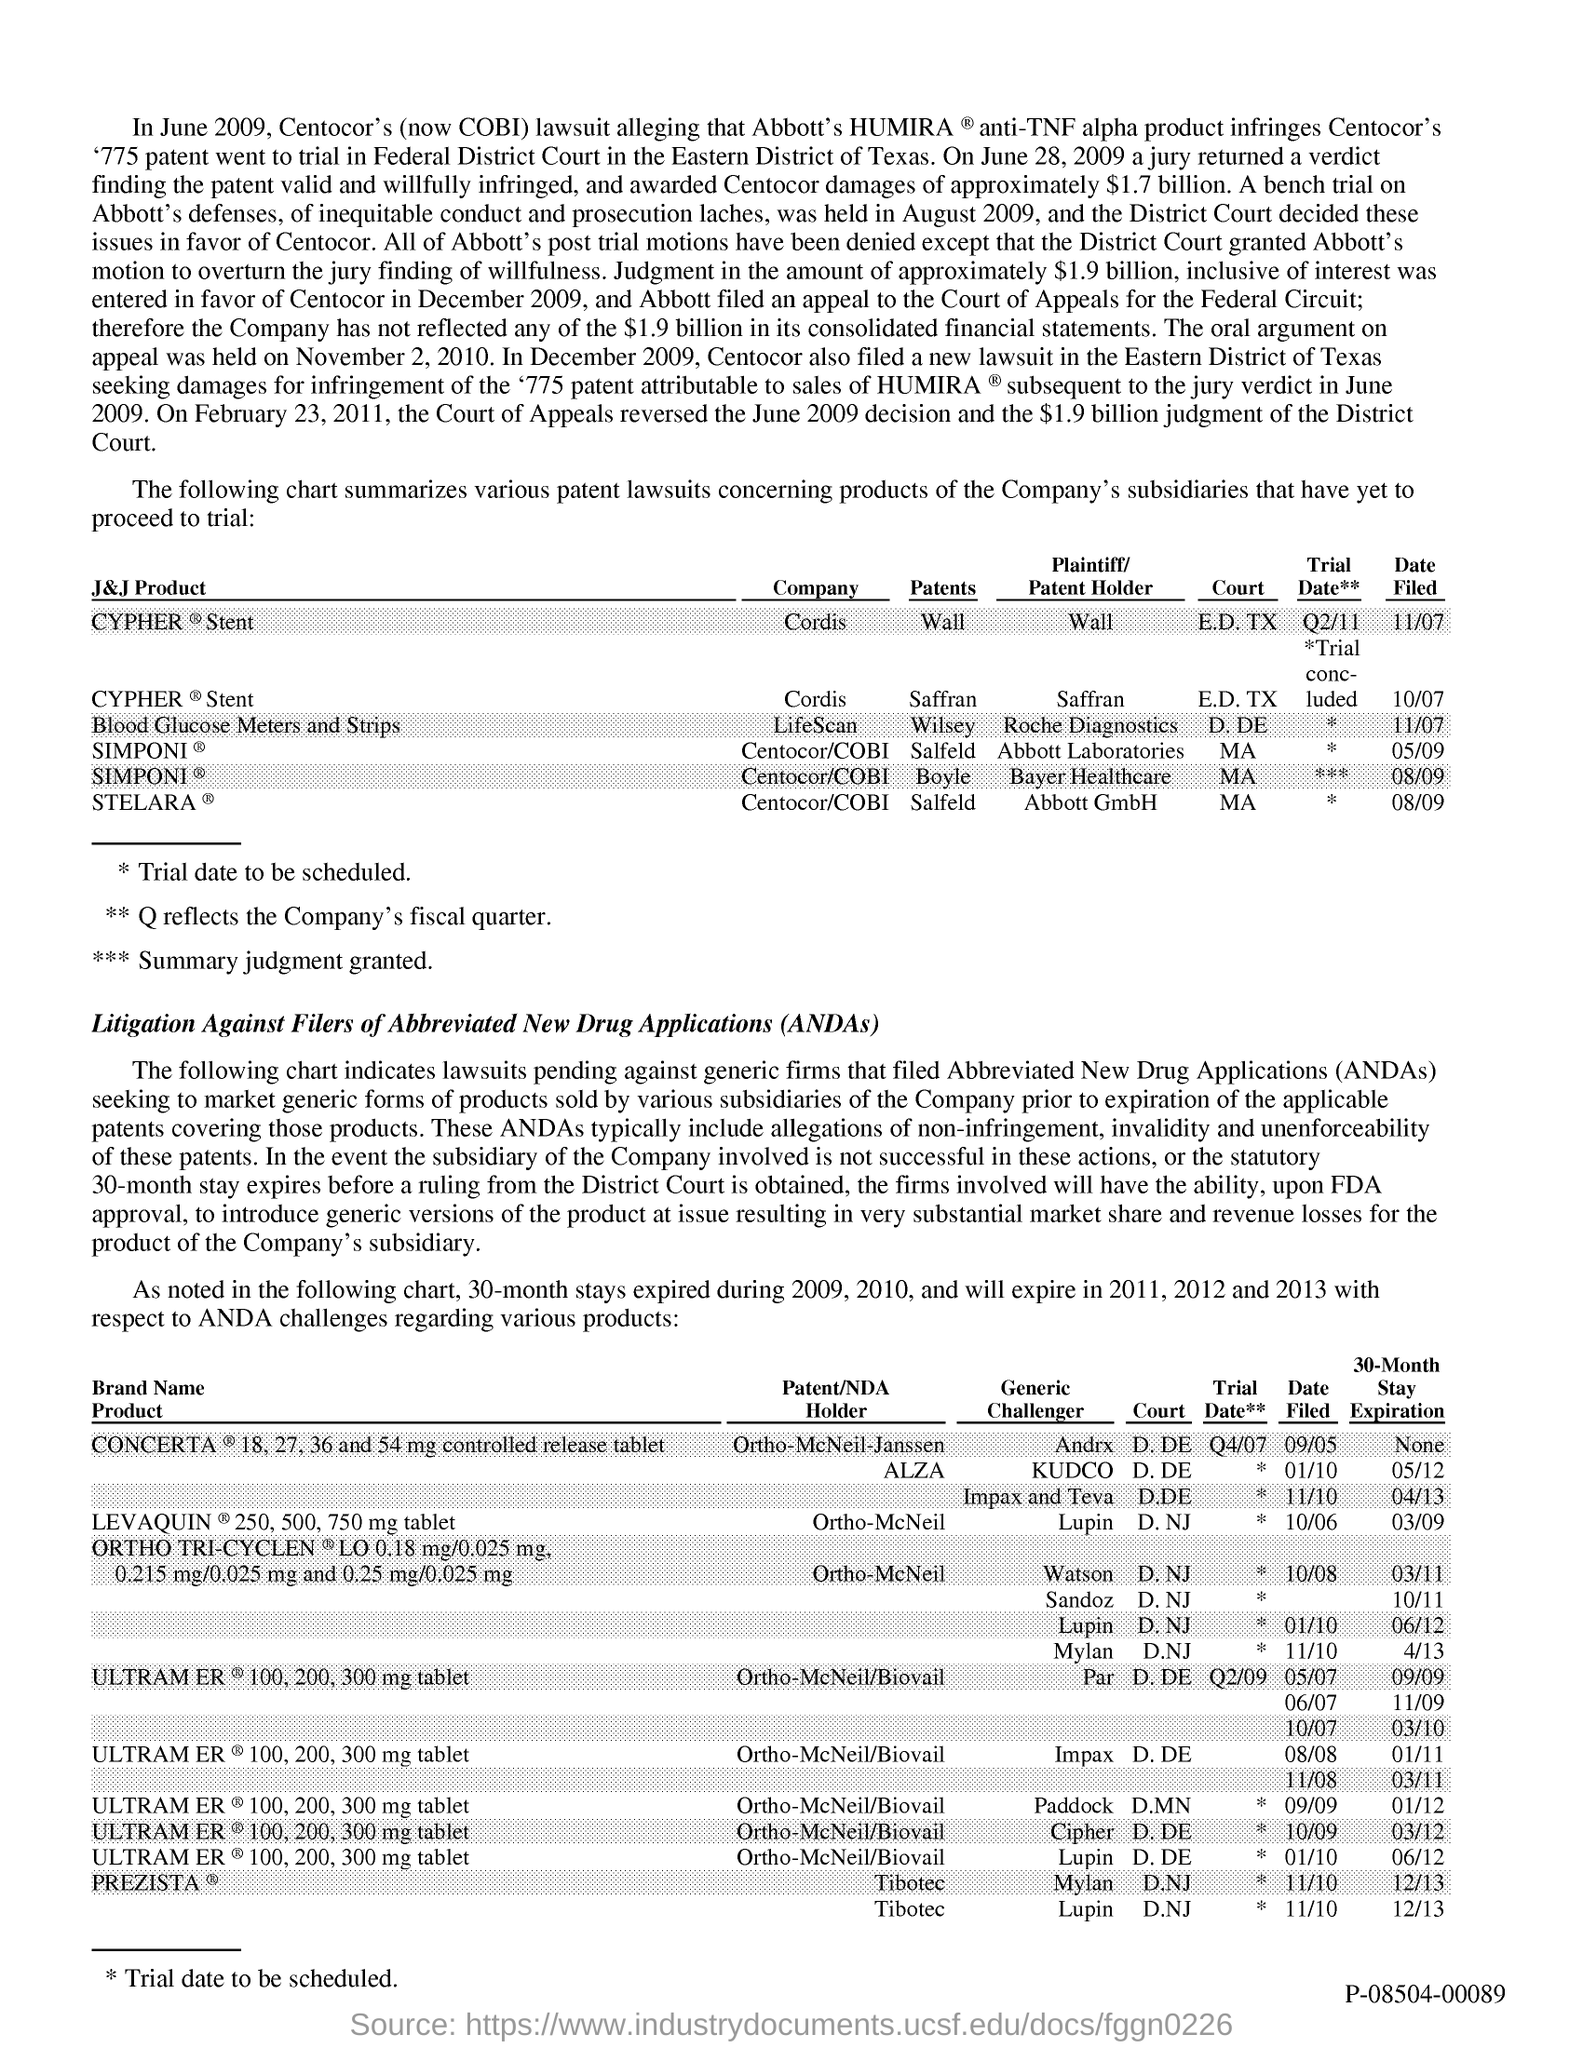What is the fullform of ANDAs?
Offer a terse response. Abbreviated New Drug Applications. 